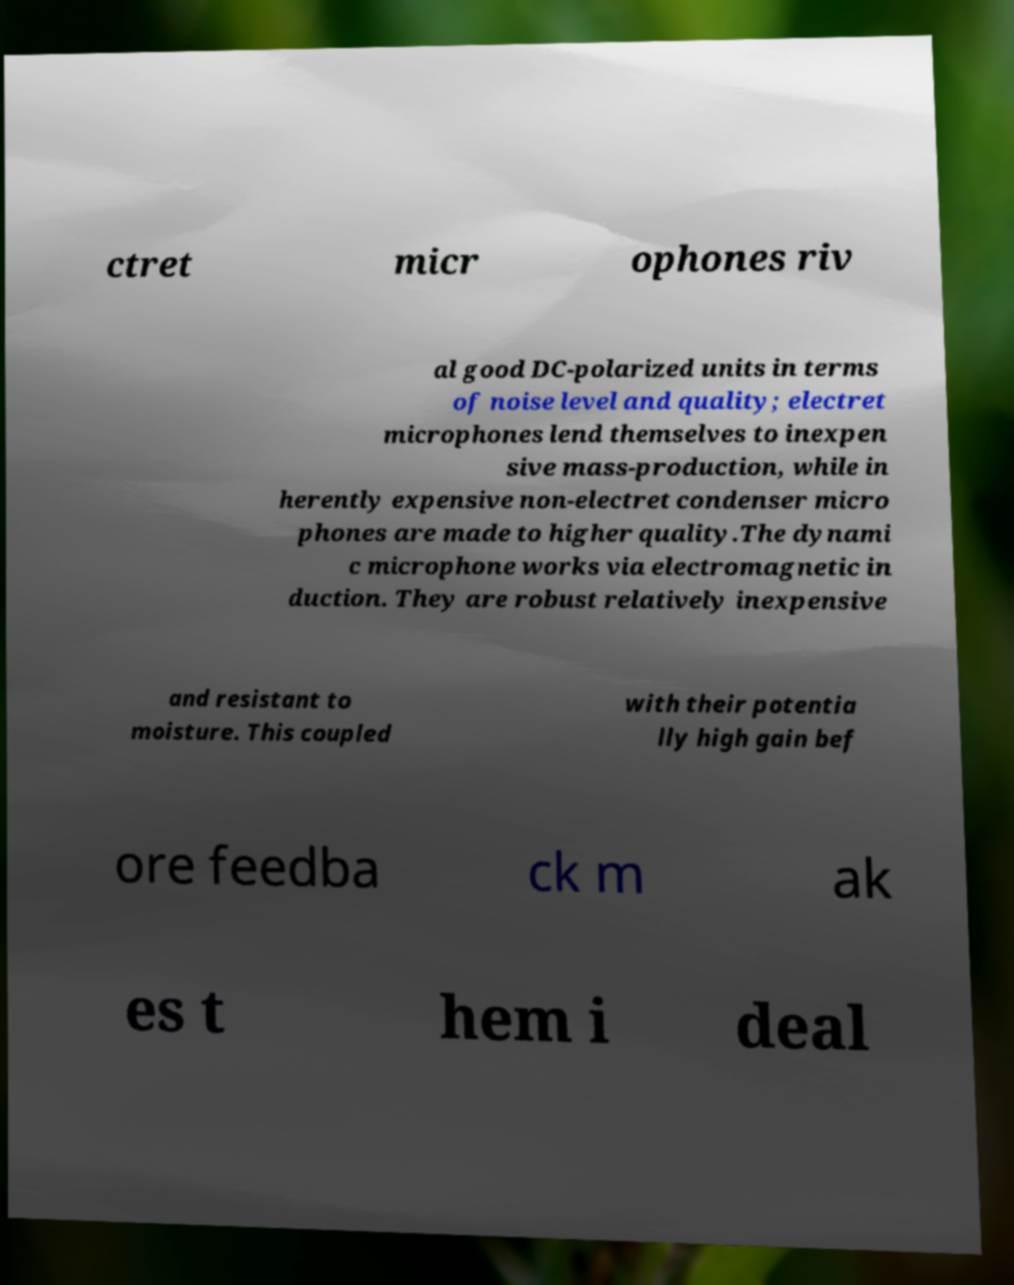What messages or text are displayed in this image? I need them in a readable, typed format. ctret micr ophones riv al good DC-polarized units in terms of noise level and quality; electret microphones lend themselves to inexpen sive mass-production, while in herently expensive non-electret condenser micro phones are made to higher quality.The dynami c microphone works via electromagnetic in duction. They are robust relatively inexpensive and resistant to moisture. This coupled with their potentia lly high gain bef ore feedba ck m ak es t hem i deal 